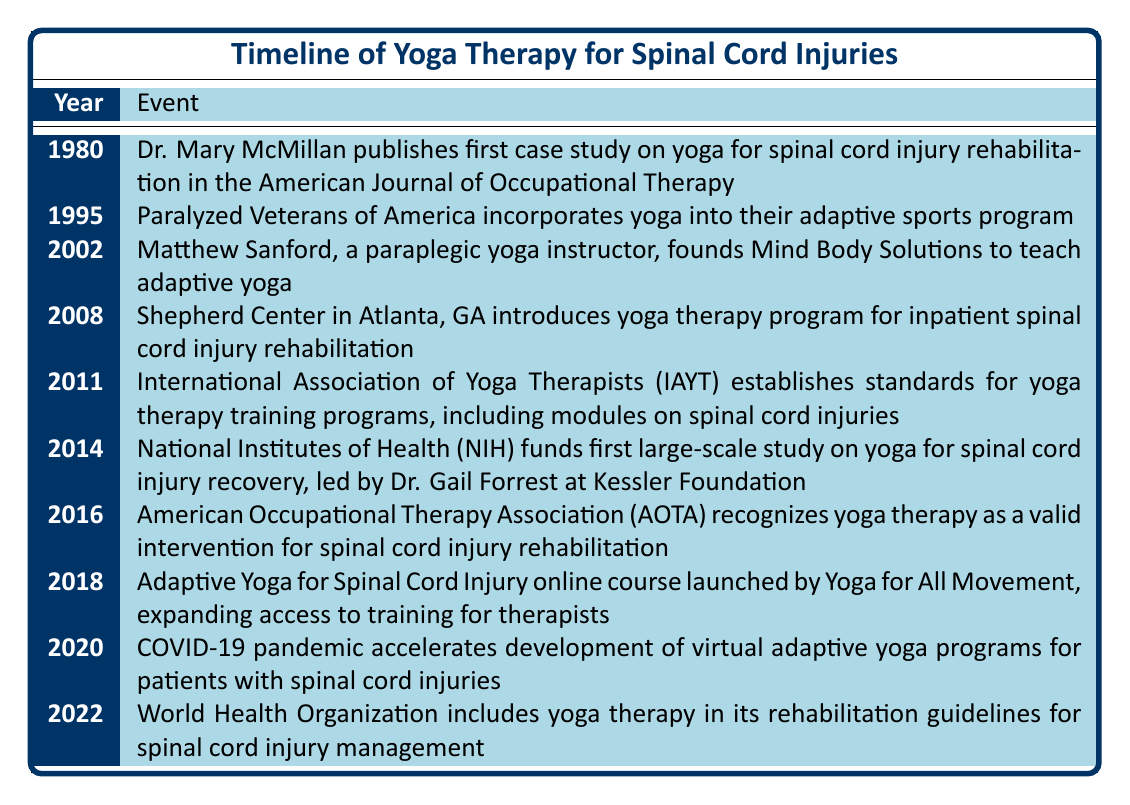What year did Dr. Mary McMillan publish the first case study on yoga for spinal cord injury rehabilitation? The table specifies that this event occurred in 1980.
Answer: 1980 What significant event related to yoga therapy for spinal cord injuries happened in 2014? In 2014, the National Institutes of Health funded the first large-scale study on yoga for spinal cord injury recovery, led by Dr. Gail Forrest at Kessler Foundation.
Answer: NIH funded the first large-scale study How many years after the publication of the first case study was the adaptive yoga course launched in 2018? The first case study was published in 1980, and the adaptive yoga course was launched in 2018. Therefore, subtracting 1980 from 2018 gives 38 years.
Answer: 38 years Did the American Occupational Therapy Association recognize yoga therapy before or after 2016? According to the table, the AOTA recognized yoga therapy as a valid intervention for spinal cord injury rehabilitation in 2016, which means it was recognized in that same year.
Answer: In 2016 Which organization established standards for yoga therapy training programs related to spinal cord injuries, and in what year? The International Association of Yoga Therapists established these standards in 2011, as indicated in the table.
Answer: IAYT in 2011 Between which years was there a significant advancement in yoga therapy for spinal cord injuries regarding the expansion of therapy access? The table shows that the adaptive yoga course launched in 2018 broadened access to training for therapists, which is five years after the AOTA recognition in 2016. The significant advancement thus occurred between 2011 and 2018.
Answer: 2011 and 2018 What is the relationship between the introduction of the yoga therapy program at the Shepherd Center and the establishment of standards by the IAYT? The yoga therapy program was introduced at the Shepherd Center in 2008 and occurred before the IAYT established training standards in 2011, indicating that the implementation of yoga therapy programs began before standardization of training.
Answer: The program preceded the standards How did the COVID-19 pandemic impact adaptive yoga for spinal cord injuries? The table indicates that the pandemic in 2020 accelerated the development of virtual adaptive yoga programs for patients with spinal cord injuries, highlighting its impact.
Answer: It accelerated virtual program development 